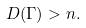<formula> <loc_0><loc_0><loc_500><loc_500>D ( \Gamma ) > n .</formula> 